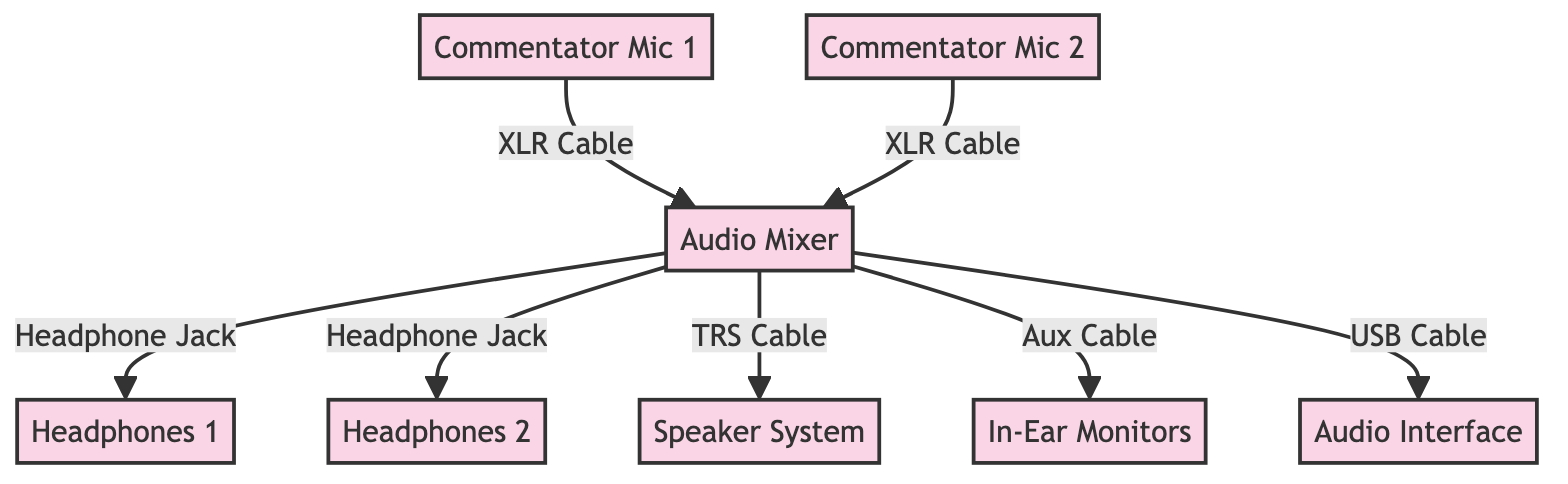What are the types of microphones used in the system? The diagram lists two microphones: "Commentator Microphone 1" and "Commentator Microphone 2", both of which are clearly labeled as nodes.
Answer: Commentator Microphone 1, Commentator Microphone 2 How many headphones are shown in the diagram? The diagram indicates a total of two headphone nodes labeled "Headphones 1" and "Headphones 2", which can be counted directly from the diagram.
Answer: 2 What type of cable connects the first commentator microphone to the audio mixer? The diagram specifies that "Commentator Mic 1" connects to "Audio Mixer" via an "XLR Cable", directly illustrated in the link.
Answer: XLR Cable What type of equipment receives audio signals from the audio mixer? Three types of equipment receive audio signals from the mixer: "Headphones 1", "Headphones 2", and "Speaker System", as indicated by the links leading away from the "Audio Mixer" node.
Answer: Headphones 1, Headphones 2, Speaker System Which device connects to the audio mixer via a USB cable? The diagram shows "Audio Interface" as the node connected to the "Audio Mixer" with a "USB Cable," which is clearly labeled.
Answer: Audio Interface What is the total number of nodes in the diagram? Counting all the individual hardware nodes (Audio Mixer, both Commentator Microphones, two Headphones, Speaker System, In-Ear Monitors, and Audio Interface) gives a total of seven distinct nodes in the diagram.
Answer: 7 Which monitoring equipment connects directly to the audio mixer using 'Aux' cable? The "In-Ear Monitors" node is connected to the "Audio Mixer" by an "Aux Cable," which is indicated in the link between these two nodes.
Answer: In-Ear Monitors How many types of cables are depicted in the diagram? There are five distinct types of cables shown between the nodes: XLR Cable, Headphone Jack, TRS Cable, Aux Cable, and USB Cable, which can be counted from the labeled links.
Answer: 5 What is the purpose of the audio mixer in this system? The audio mixer serves as the central control unit that receives input from microphones and routes audio signals to various output devices such as headphones, speakers, and in-ear monitors, as indicated by its connections.
Answer: Central control unit 